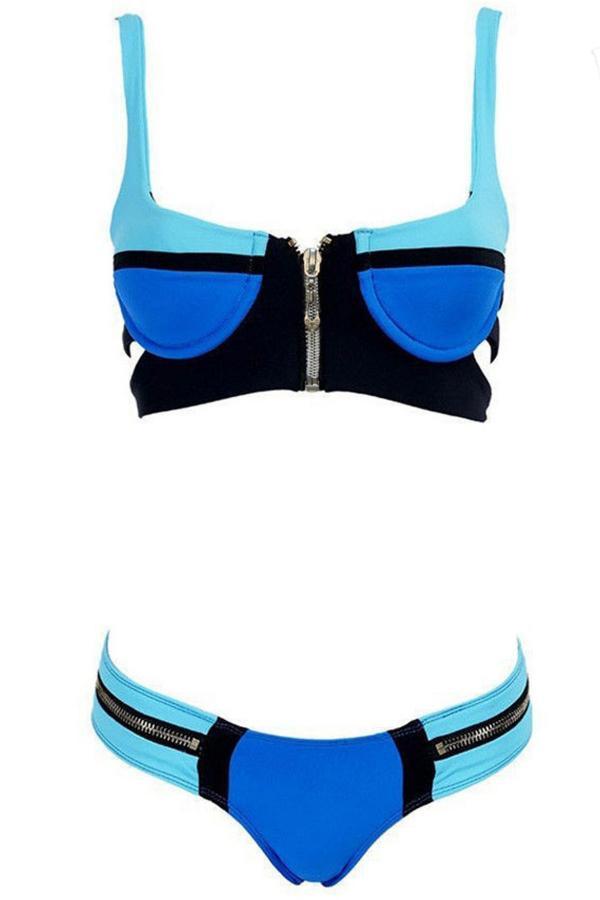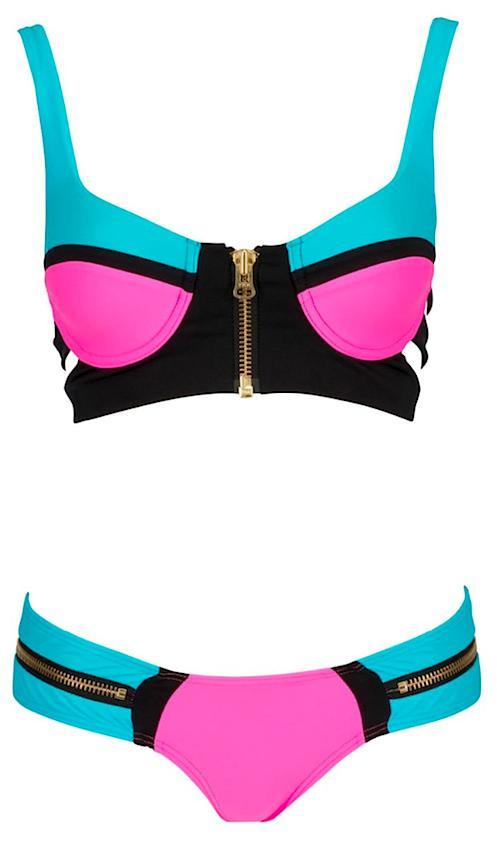The first image is the image on the left, the second image is the image on the right. Analyze the images presented: Is the assertion "All bikini tops are over-the-shoulder style, rather than tied around the neck." valid? Answer yes or no. Yes. 